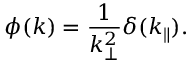<formula> <loc_0><loc_0><loc_500><loc_500>\phi ( k ) = \frac { 1 } { k _ { \bot } ^ { 2 } } \delta ( k _ { \| } ) .</formula> 